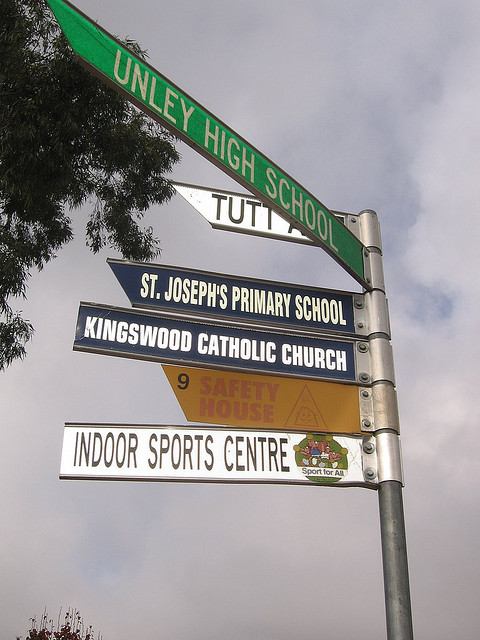Please transcribe the text information in this image. UNLEY HIGH SCHOOL ST. JOSEPH'S for SPORT CENTRE SPORTS INDOOR HOUSE SAFETY 9 CHURCH CATHOLIC KINGSWOOD SCHOOL PRIMARY TUTT 